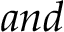<formula> <loc_0><loc_0><loc_500><loc_500>a n d</formula> 